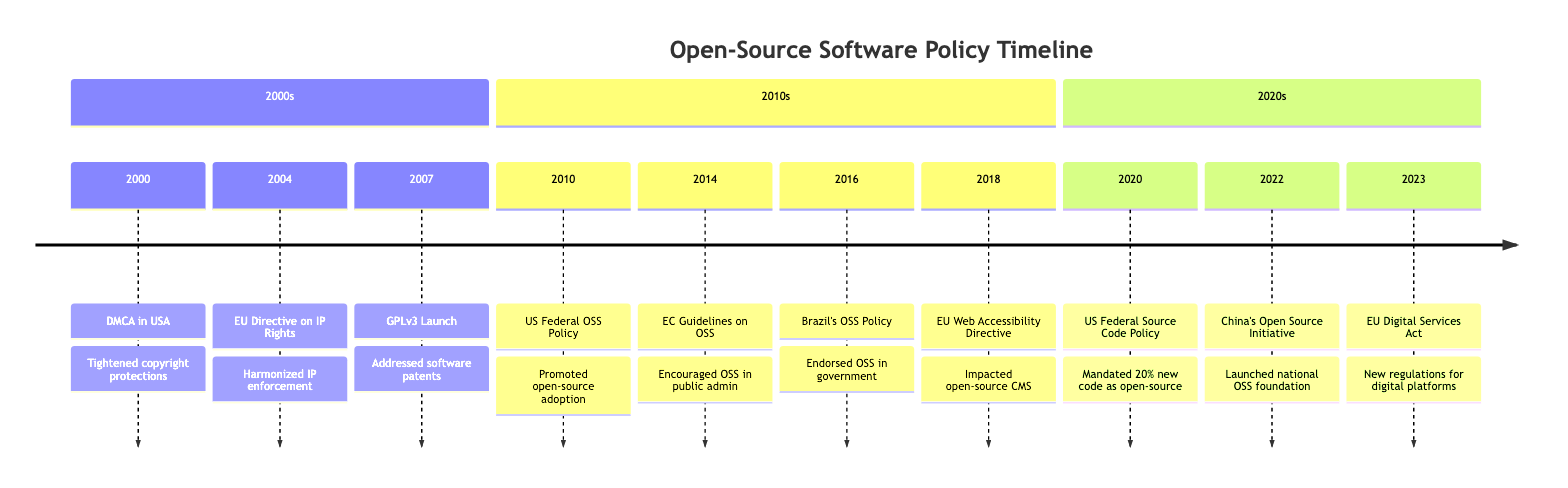What legislation was introduced in 2000 affecting open-source software? The diagram clearly indicates that the DMCA was introduced in 2000. This marks it as the first relevant legislation affecting open-source software mentioned in the timeline.
Answer: DMCA What year saw the launch of GPLv3? The timeline shows that the General Public License version 3 (GPLv3) was launched in 2007. This is explicitly stated in the respective section for the 2000s.
Answer: 2007 How many significant events regarding open-source policies occurred in the 2010s? By examining the timeline, it is evident that there are four significant events listed for the 2010s (2010, 2014, 2016, 2018). Counting these events results in a total of four.
Answer: 4 Which event initiated the promotion of open-source software by the US federal government? According to the timeline, the US Federal Government’s Open Source Software Policy in 2010 initiated the promotion of open-source software on a federal level.
Answer: US Federal OSS Policy What was the primary aim of the European Commission’s guidelines introduced in 2014? The 2014 GUIDELINES on Sharing and Reusing OSS aimed to encourage the use of open-source software within public administrations to improve efficiency and cost savings, as described in the event's details on the timeline.
Answer: Improve efficiency Which two events mentioned in the timeline are directly related to enhancing transparency in government software use? The events from the timeline are the US Federal OSS Policy (2010) and Brazil's OSS Policy (2016), both emphasizing the need for transparency in government projects as noted in their respective descriptions.
Answer: US Federal OSS Policy, Brazil's OSS Policy How did the Digital Services Act of 2023 impact open-source software? The EU Digital Services Act (DSA) of 2023 introduced new regulations that specifically address transparency and user data management for digital platforms, including open-source software projects, according to the event description in the timeline.
Answer: Transparency and user data management What major change did the US Federal Source Code Policy call for in 2020? The timeline specifies that the US Federal Source Code Policy mandated federal agencies to publish at least 20% of new custom-developed code as open source, making it a significant policy change focused on software reusability.
Answer: 20% new code Which country's policy specifically endorsed open-source software in government projects in 2016? Referring to the timeline, Brazil's introduction of the Government Use of Open Source Software policy in 2016 is the specified endorsement of open-source software in government projects.
Answer: Brazil 